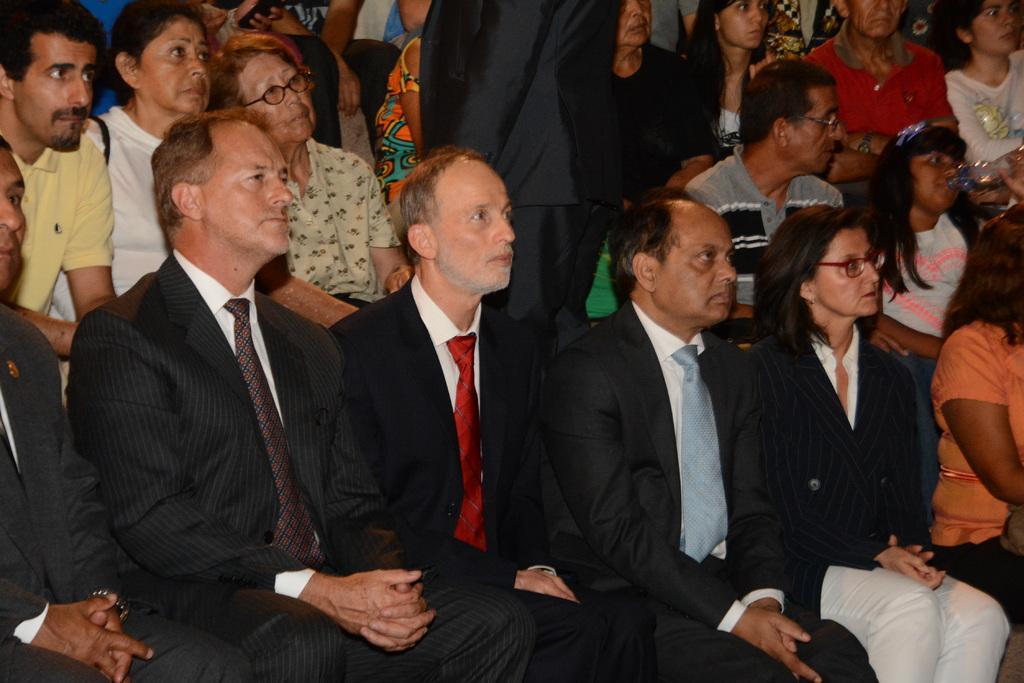Could you give a brief overview of what you see in this image? Here there are few persons sitting on the chairs and in the middle a person is standing and on the right a girl is drinking water. 